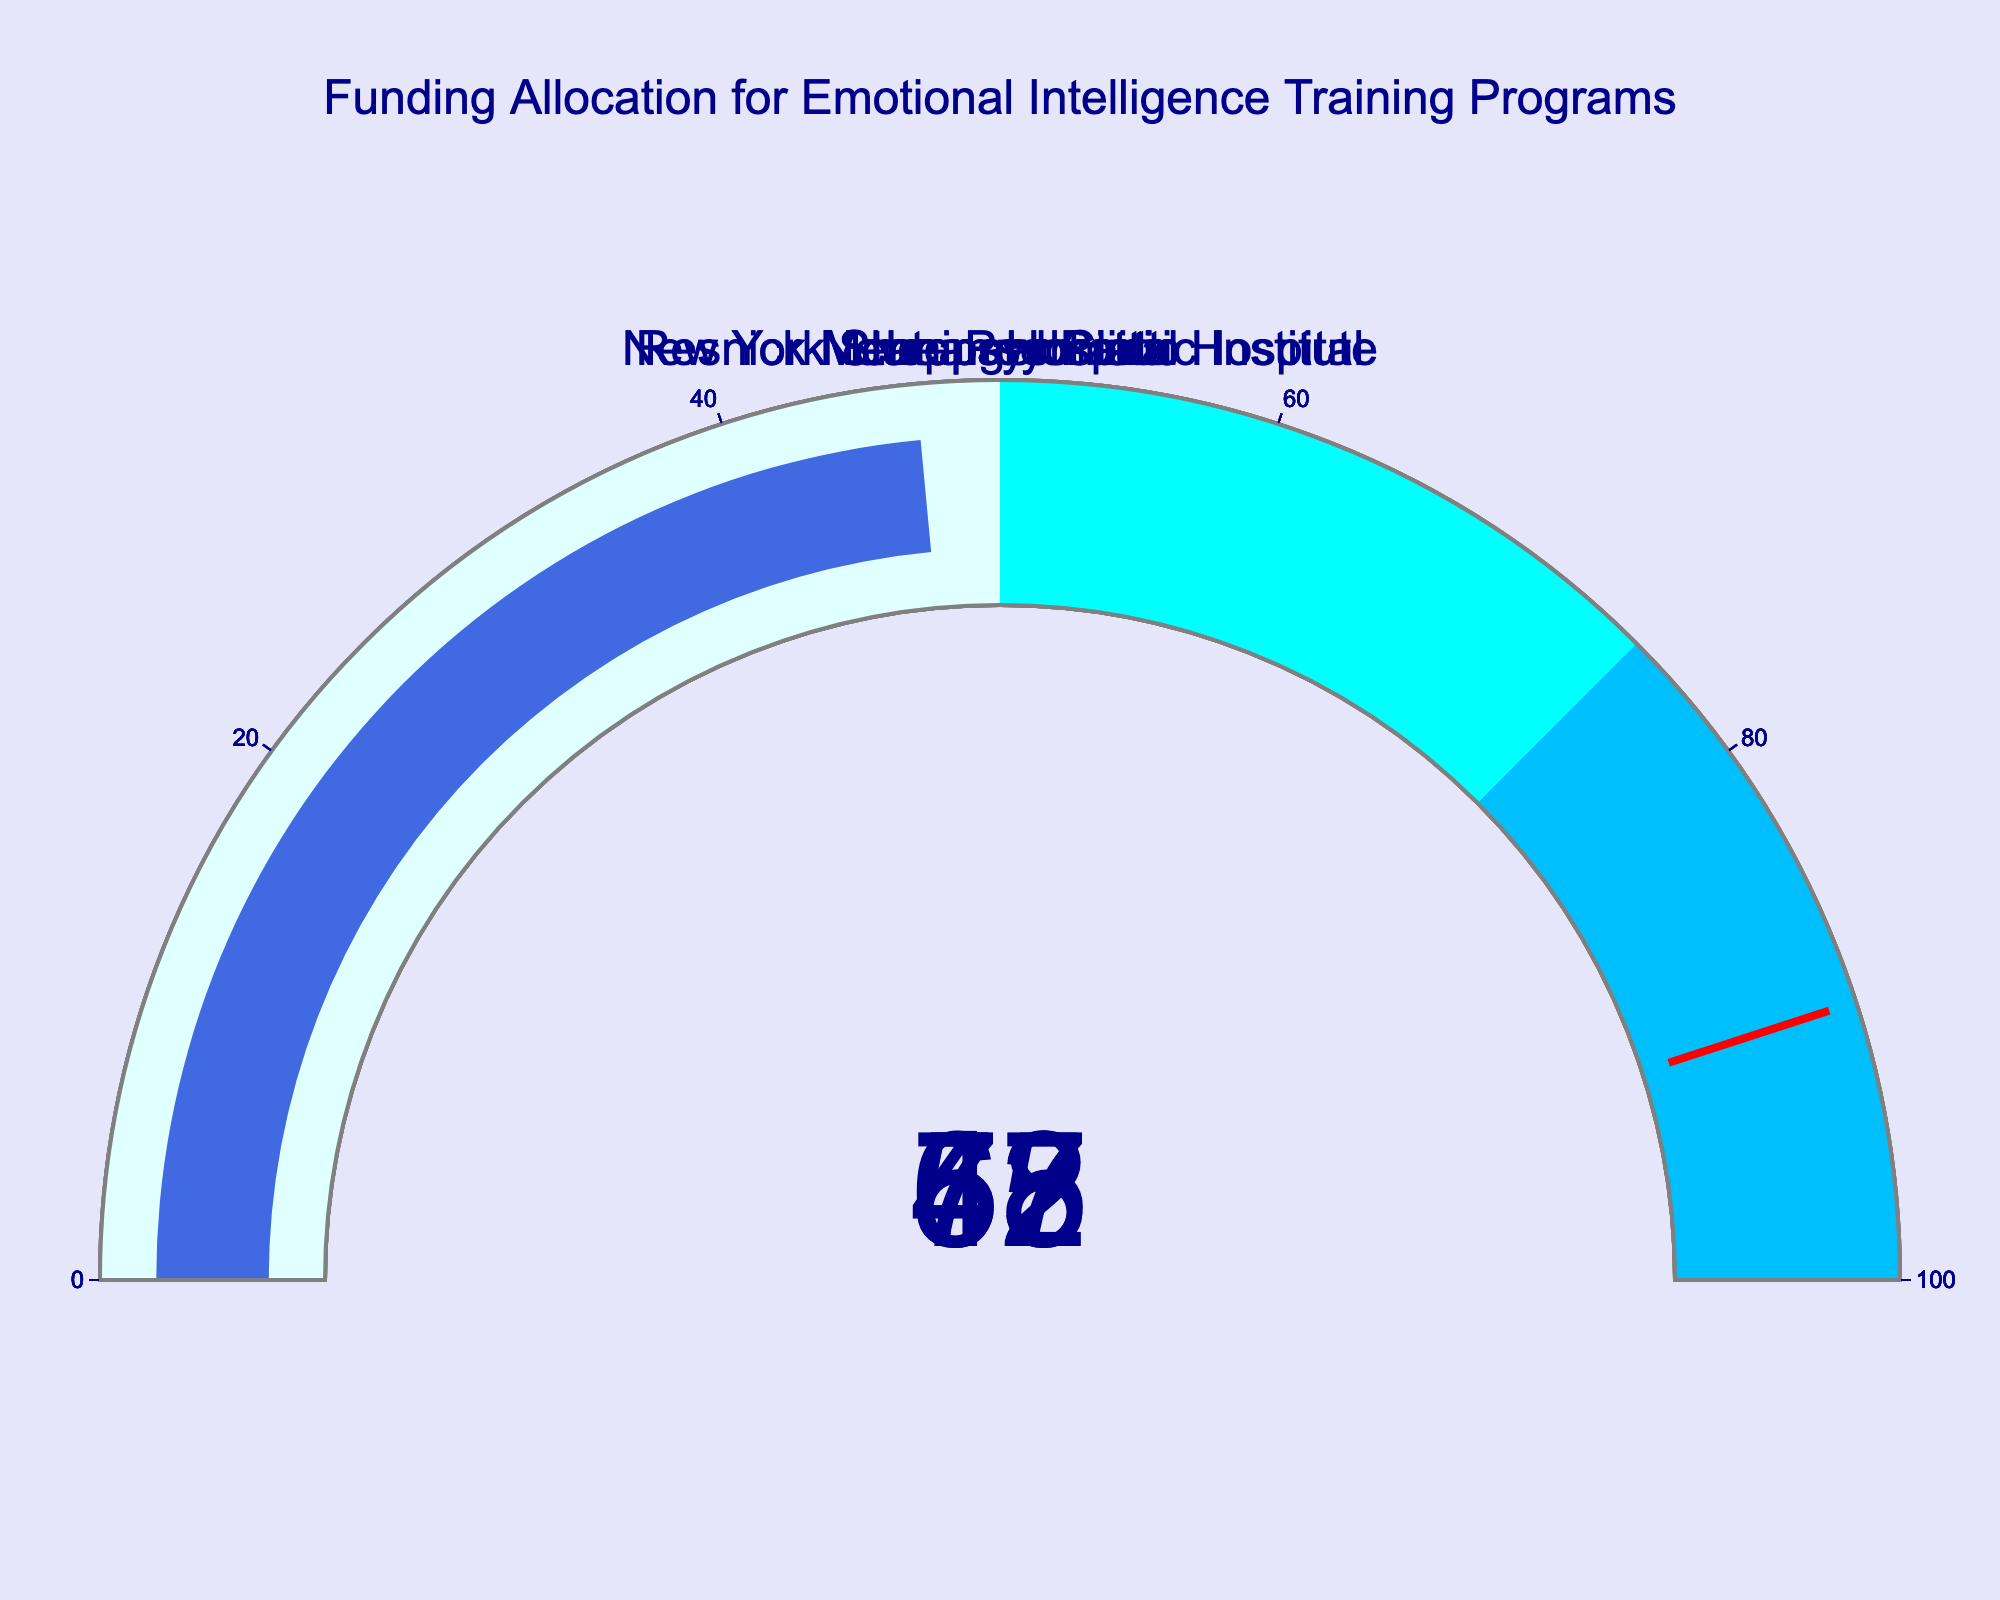What is the funding percentage for the McLean Hospital? Look at the gauge labeled "McLean Hospital" and read the indicated percentage.
Answer: 65 Which institution has the highest funding percentage? Compare the numbers on all gauges and find the highest value.
Answer: New York State Psychiatric Institute What is the combined funding percentage of Sheppard Pratt and Resnick Neuropsychiatric Hospital? Add the funding percentages of both institutions: 53 + 47.
Answer: 100 Is the funding for the Menninger Clinic above or below 60%? Look at the gauge labeled "Menninger Clinic" and compare its value to 60%.
Answer: Below Which institutions have a funding percentage less than 60%? Identify those with values under 60%: below 60 are Menninger Clinic, Sheppard Pratt, and Resnick Neuropsychiatric Hospital.
Answer: Menninger Clinic, Sheppard Pratt, Resnick Neuropsychiatric Hospital What is the average funding percentage for all institutions? Calculate the mean of the percentages: (72 + 65 + 58 + 53 + 47) / 5.
Answer: 59 How much more funding does New York State Psychiatric Institute have compared to Resnick Neuropsychiatric Hospital? Subtract the funding percentage of Resnick Neuropsychiatric Hospital from New York State Psychiatric Institute: 72 - 47.
Answer: 25 Which institution’s funding is closest to 50%? Compare all funding percentages to 50% and find the closest: 47, 53.
Answer: Sheppard Pratt 